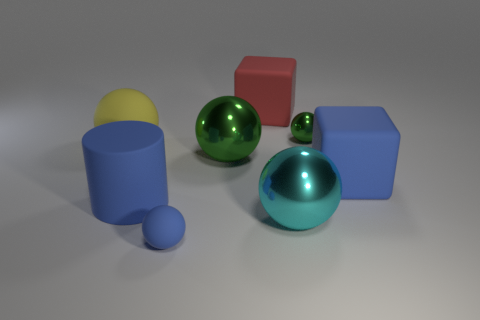Are there fewer cyan metal things than large cyan matte spheres?
Provide a short and direct response. No. Is there a blue ball?
Give a very brief answer. Yes. What number of other things are there of the same size as the blue cube?
Your response must be concise. 5. Does the red thing have the same material as the big ball that is in front of the blue block?
Ensure brevity in your answer.  No. Are there the same number of red objects that are to the right of the tiny green shiny thing and rubber cubes to the left of the big yellow rubber thing?
Give a very brief answer. Yes. What is the material of the cyan ball?
Your answer should be compact. Metal. There is another metallic ball that is the same size as the blue sphere; what is its color?
Offer a very short reply. Green. There is a big blue cylinder that is left of the tiny blue thing; is there a block that is left of it?
Your answer should be very brief. No. What number of cubes are either green matte things or large red rubber objects?
Give a very brief answer. 1. How big is the blue object behind the blue matte object that is to the left of the small thing to the left of the large cyan ball?
Your response must be concise. Large. 